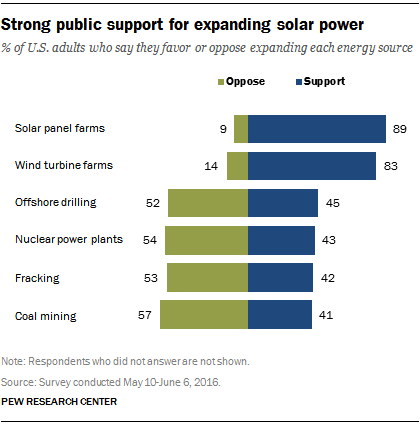Identify some key points in this picture. The second largest bar value in the graph is 83. The result of taking the sum of the two smallest green bars and the smallest blue bars and deducting the smaller value from the larger value is 18. 